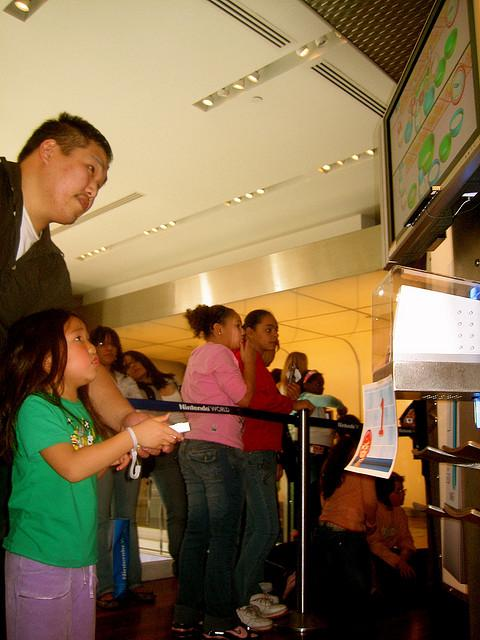What does the child hold in her hands? remote 